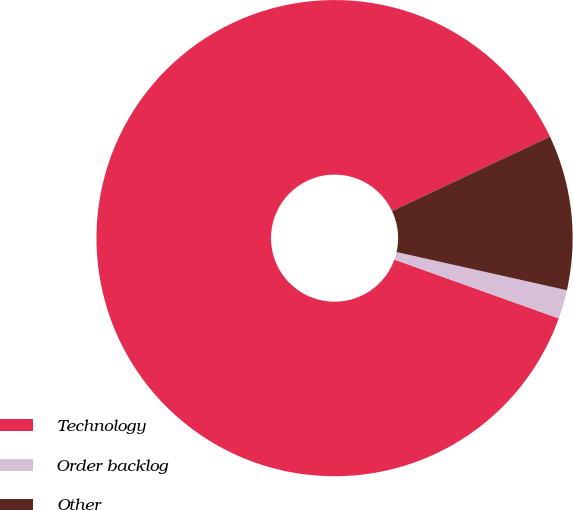<chart> <loc_0><loc_0><loc_500><loc_500><pie_chart><fcel>Technology<fcel>Order backlog<fcel>Other<nl><fcel>87.52%<fcel>1.96%<fcel>10.52%<nl></chart> 